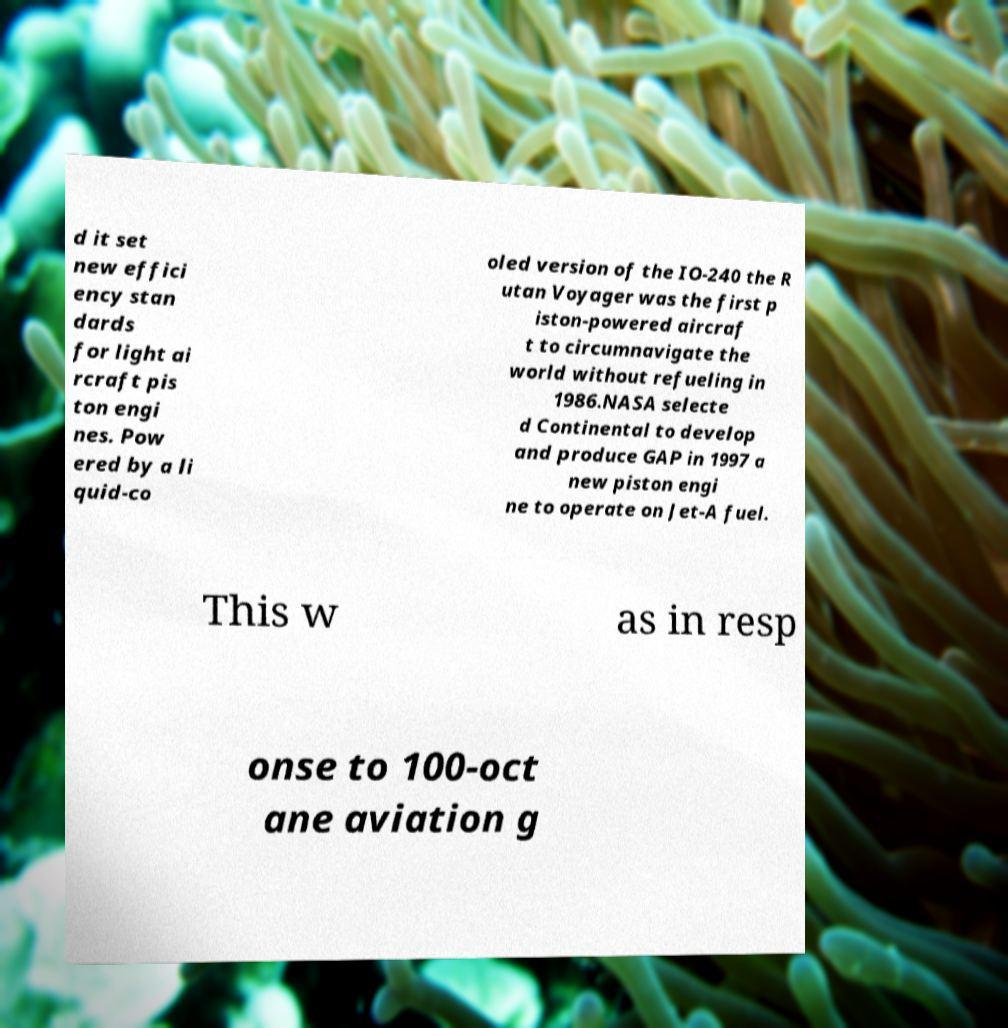Can you read and provide the text displayed in the image?This photo seems to have some interesting text. Can you extract and type it out for me? d it set new effici ency stan dards for light ai rcraft pis ton engi nes. Pow ered by a li quid-co oled version of the IO-240 the R utan Voyager was the first p iston-powered aircraf t to circumnavigate the world without refueling in 1986.NASA selecte d Continental to develop and produce GAP in 1997 a new piston engi ne to operate on Jet-A fuel. This w as in resp onse to 100-oct ane aviation g 